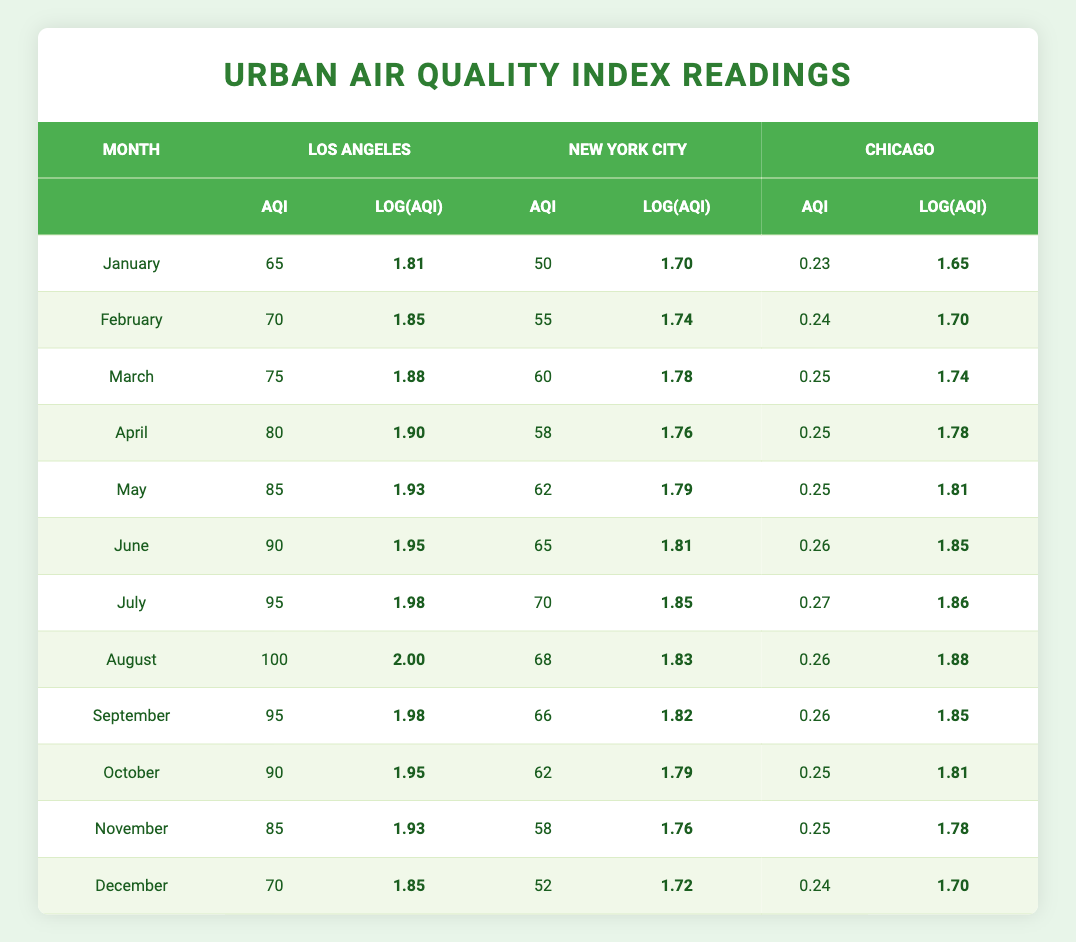What is the AQI for Los Angeles in April? According to the table, the AQI value for Los Angeles in April is 80.
Answer: 80 What is the logarithmic value of the AQI for New York City in August? The table shows the AQI for New York City in August is 68, and the logarithmic value is approximately 1.83.
Answer: 1.83 Which city had the highest AQI value in June? In June, Los Angeles had an AQI of 90, New York City had 65, and Chicago had 70. Therefore, Los Angeles had the highest AQI.
Answer: Los Angeles What is the average AQI for all three cities combined in December? The AQI for Los Angeles in December is 70, New York City is 52, and Chicago is 50. The average is (70 + 52 + 50) / 3 = 57.33, which rounds to 57.
Answer: 57 Did Chicago have a lower AQI than New York City in March? In March, Chicago had an AQI of 55 while New York City had an AQI of 60. Therefore, Chicago did have a lower AQI.
Answer: Yes What is the difference in the AQI readings for Los Angeles from January to August? The AQI for Los Angeles in January is 65 and in August is 100. The difference is 100 - 65 = 35.
Answer: 35 What was the highest monthly AQI reading for New York City during the year? The highest AQI for New York City occurred in July with a reading of 70.
Answer: 70 In which month did Los Angeles and Chicago have the closest AQI values? In September, Los Angeles had an AQI of 95 and Chicago had an AQI of 70, making their values 25 apart. The closest month is March when Los Angeles had 75 and Chicago had 55, with a difference of 20. Thus, in March, they had their closest AQI values.
Answer: March What is the logarithmic value of the highest AQI recorded in the entire table? The highest AQI recorded is 100 for Los Angeles in August. The logarithmic value can be calculated as log10(100) = 2.00.
Answer: 2.00 